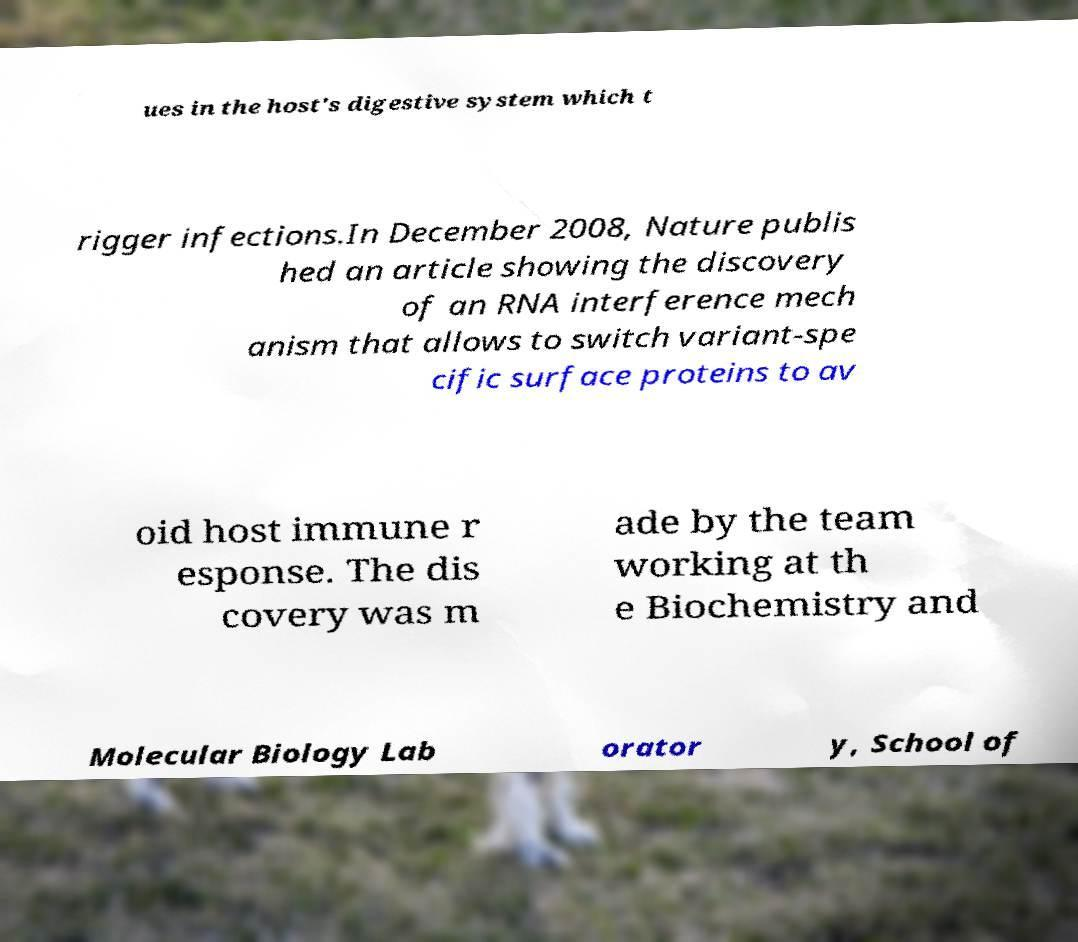Please read and relay the text visible in this image. What does it say? ues in the host's digestive system which t rigger infections.In December 2008, Nature publis hed an article showing the discovery of an RNA interference mech anism that allows to switch variant-spe cific surface proteins to av oid host immune r esponse. The dis covery was m ade by the team working at th e Biochemistry and Molecular Biology Lab orator y, School of 